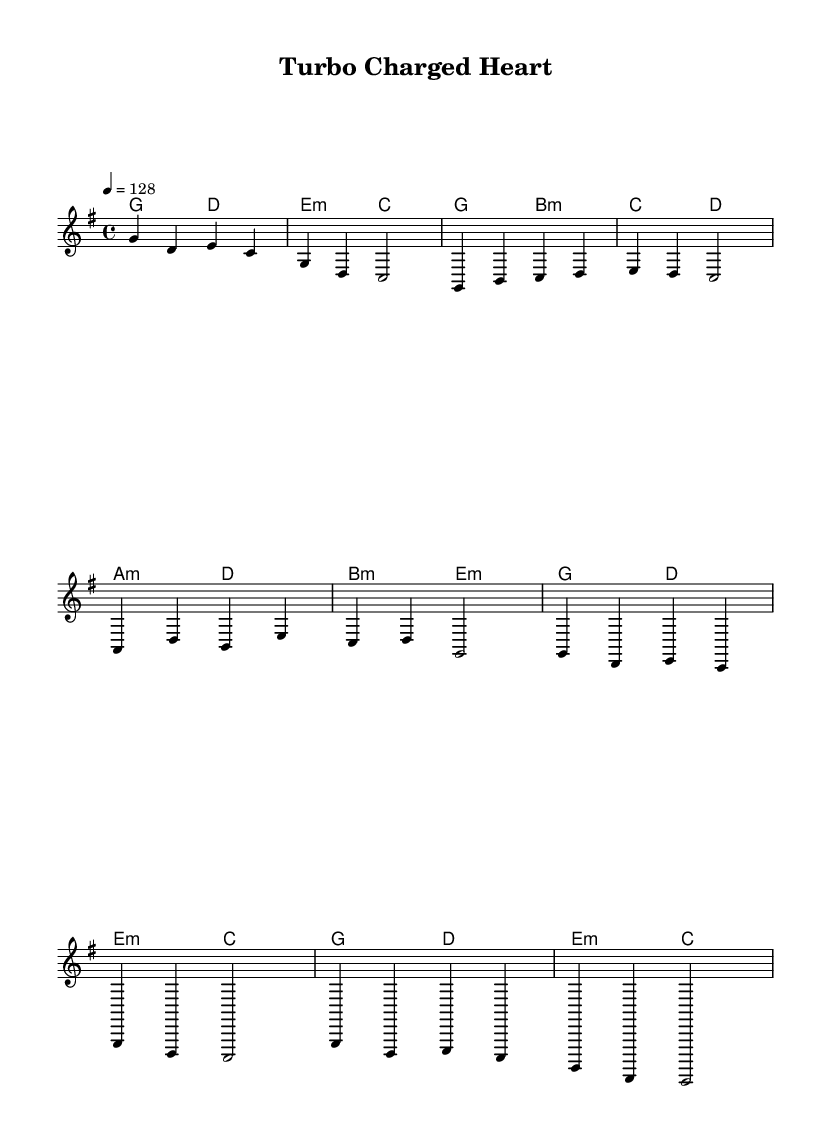What is the key signature of this music? The key signature displayed at the beginning of the score is G major, which consists of one sharp note (F#).
Answer: G major What is the time signature of this music? The time signature is located at the beginning and indicates that there are four beats in each measure, which corresponds to a 4/4 time signature.
Answer: 4/4 What is the tempo marking of this piece? The tempo marking, located under the \tempo command, shows that the piece should be played at a speed of 128 beats per minute.
Answer: 128 How many measures are there in the chorus section? By examining the rendered staff, we count the number of measures in the chorus section, which consists of four distinct measures.
Answer: 4 What is the musical form of this composition based on the sections? The music progresses through clearly defined sections: an introduction, a verse, a pre-chorus, and a chorus, indicating a common pop structure.
Answer: Verse - Pre-Chorus - Chorus What lyrical theme does the song emphasize? The lyrics centered on themes of speed and love, particularly highlighted by phrases like "turbo charged heart" and "pedal to the metal," clearly indicating a blend of romance with racing.
Answer: Racing and love 